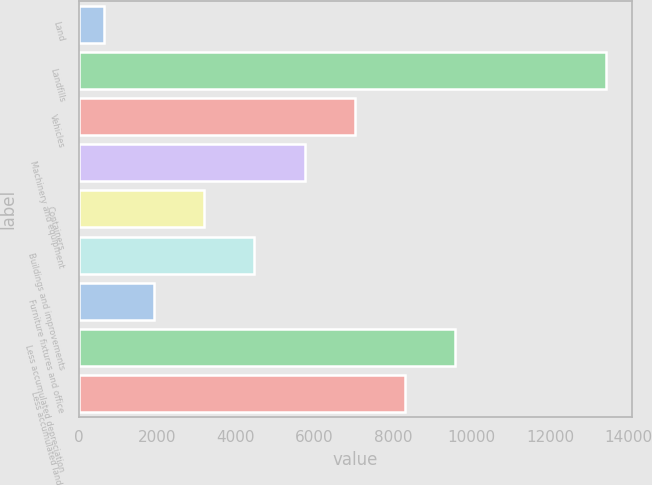Convert chart. <chart><loc_0><loc_0><loc_500><loc_500><bar_chart><fcel>Land<fcel>Landfills<fcel>Vehicles<fcel>Machinery and equipment<fcel>Containers<fcel>Buildings and improvements<fcel>Furniture fixtures and office<fcel>Less accumulated depreciation<fcel>Less accumulated landfill<nl><fcel>636<fcel>13416<fcel>7026<fcel>5748<fcel>3192<fcel>4470<fcel>1914<fcel>9582<fcel>8304<nl></chart> 